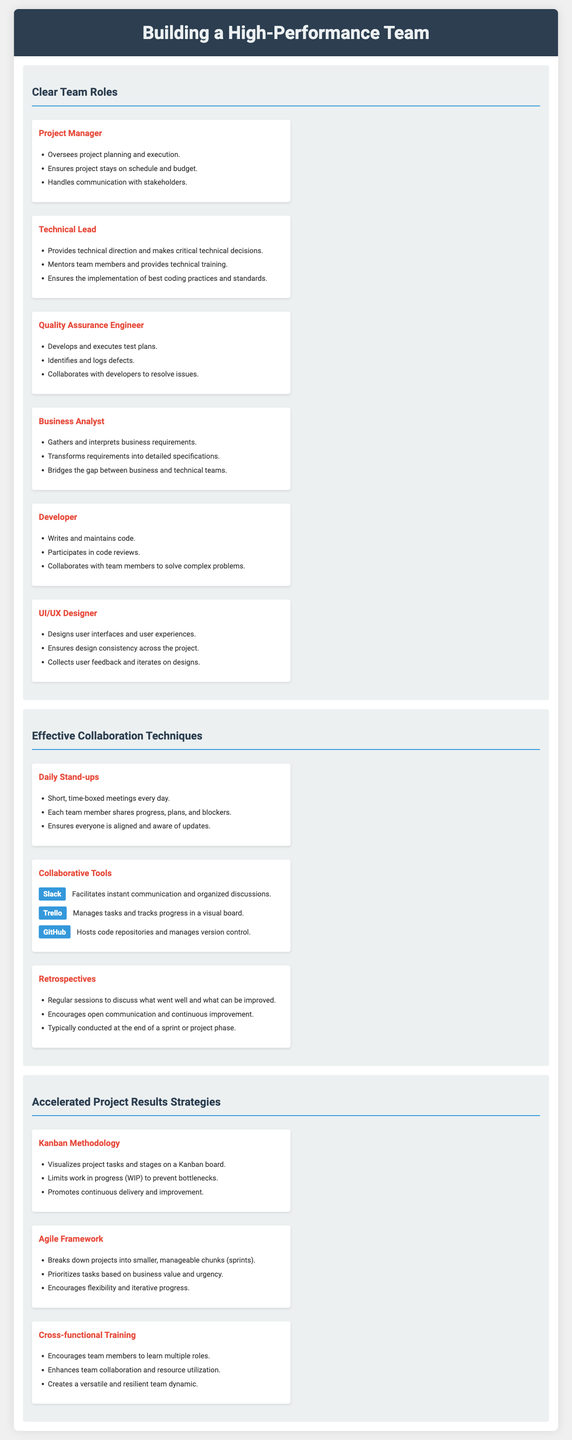What is the title of the document? The title of the document is stated at the top as "Building a High-Performance Team."
Answer: Building a High-Performance Team Who is responsible for overseeing project planning? The section detailing team roles indicates that the Project Manager oversees project planning and execution.
Answer: Project Manager What is one tool mentioned for collaborative communication? The section on collaborative tools lists Slack as a tool for instant communication and organized discussions.
Answer: Slack What methodology is suggested to visualize project tasks? The document mentions the Kanban Methodology for visualizing project tasks and stages.
Answer: Kanban Methodology Which team member is responsible for collecting user feedback? The UI/UX Designer is responsible for collecting user feedback and iterating on designs.
Answer: UI/UX Designer What is the main goal of daily stand-up meetings? The document specifies that daily stand-up meetings ensure everyone is aligned and aware of updates.
Answer: Alignment Which role specializes in gathering business requirements? The Business Analyst specializes in gathering and interpreting business requirements according to the document.
Answer: Business Analyst How frequently are retrospectives typically conducted? The document suggests that retrospectives are typically conducted at the end of a sprint or project phase.
Answer: End of a sprint What does cross-functional training enhance? The document states that cross-functional training enhances team collaboration and resource utilization.
Answer: Team collaboration What does the Agile Framework prioritize? The Agile Framework prioritizes tasks based on business value and urgency, as mentioned in the document.
Answer: Business value and urgency 